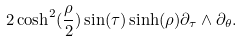Convert formula to latex. <formula><loc_0><loc_0><loc_500><loc_500>2 \cosh ^ { 2 } ( \frac { \rho } { 2 } ) \sin ( \tau ) \sinh ( \rho ) \partial _ { \tau } \wedge \partial _ { \theta } .</formula> 